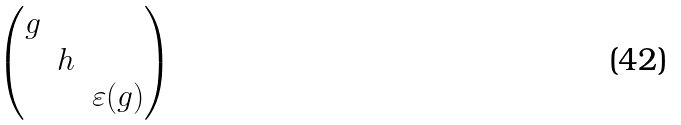<formula> <loc_0><loc_0><loc_500><loc_500>\begin{pmatrix} g \\ & h \\ & & \varepsilon ( g ) \end{pmatrix}</formula> 